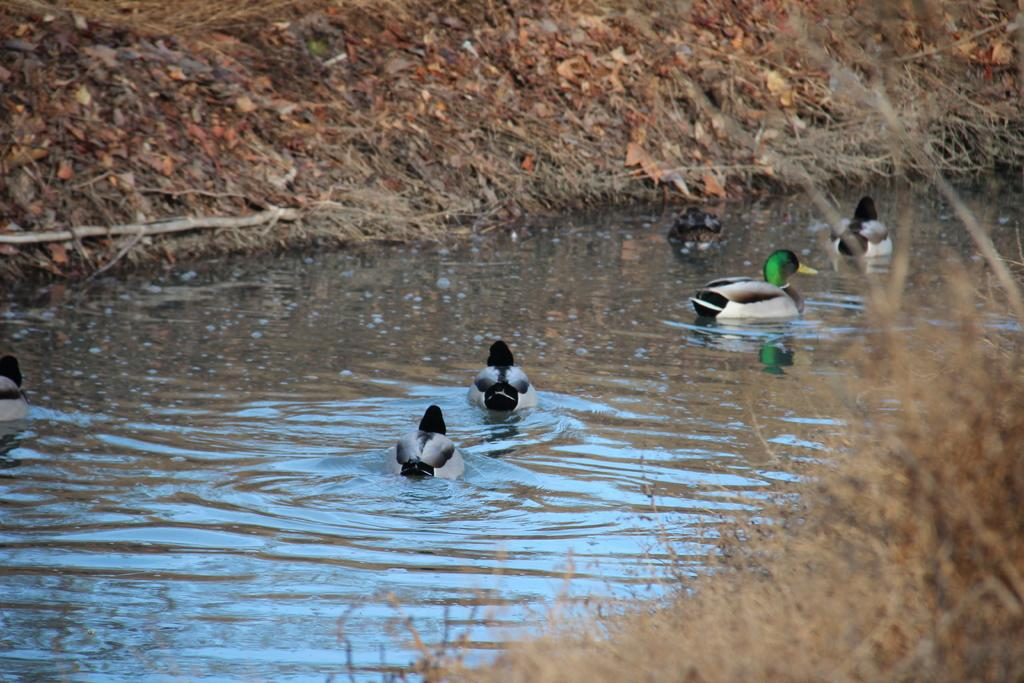What type of animals can be seen in the image? There are ducks in the water in the image. What other elements can be seen in the image besides the ducks? Plants and grass are visible in the image. How does the steam affect the ducks' driving in the image? There is no steam or driving present in the image; it features ducks in the water, plants, and grass. 